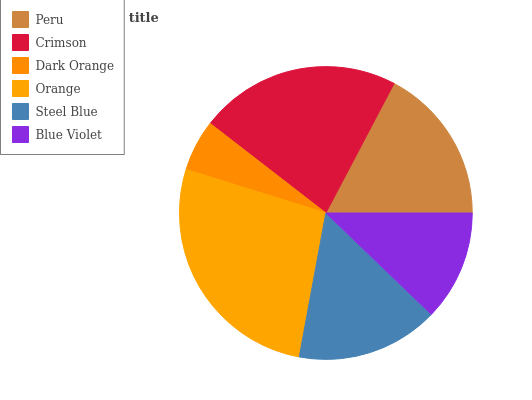Is Dark Orange the minimum?
Answer yes or no. Yes. Is Orange the maximum?
Answer yes or no. Yes. Is Crimson the minimum?
Answer yes or no. No. Is Crimson the maximum?
Answer yes or no. No. Is Crimson greater than Peru?
Answer yes or no. Yes. Is Peru less than Crimson?
Answer yes or no. Yes. Is Peru greater than Crimson?
Answer yes or no. No. Is Crimson less than Peru?
Answer yes or no. No. Is Peru the high median?
Answer yes or no. Yes. Is Steel Blue the low median?
Answer yes or no. Yes. Is Crimson the high median?
Answer yes or no. No. Is Dark Orange the low median?
Answer yes or no. No. 